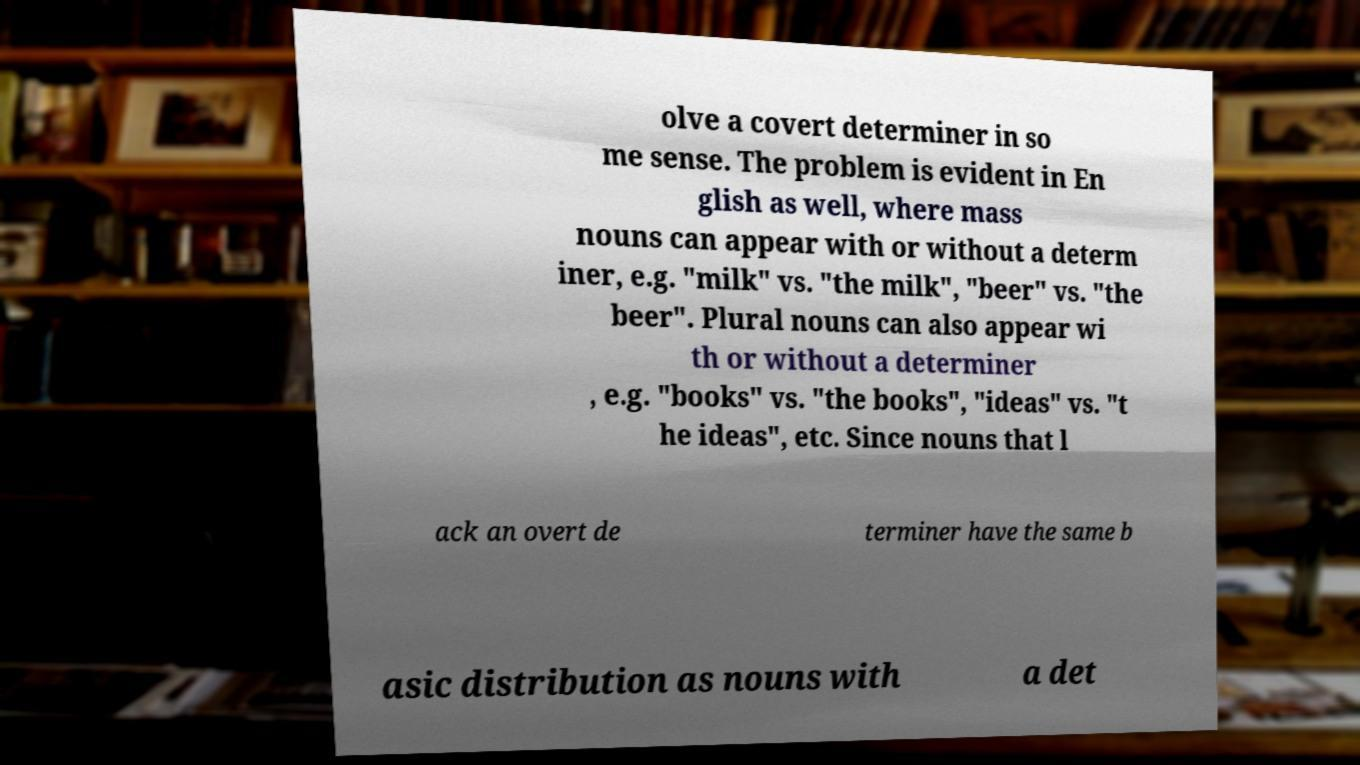Could you extract and type out the text from this image? olve a covert determiner in so me sense. The problem is evident in En glish as well, where mass nouns can appear with or without a determ iner, e.g. "milk" vs. "the milk", "beer" vs. "the beer". Plural nouns can also appear wi th or without a determiner , e.g. "books" vs. "the books", "ideas" vs. "t he ideas", etc. Since nouns that l ack an overt de terminer have the same b asic distribution as nouns with a det 